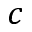<formula> <loc_0><loc_0><loc_500><loc_500>c</formula> 